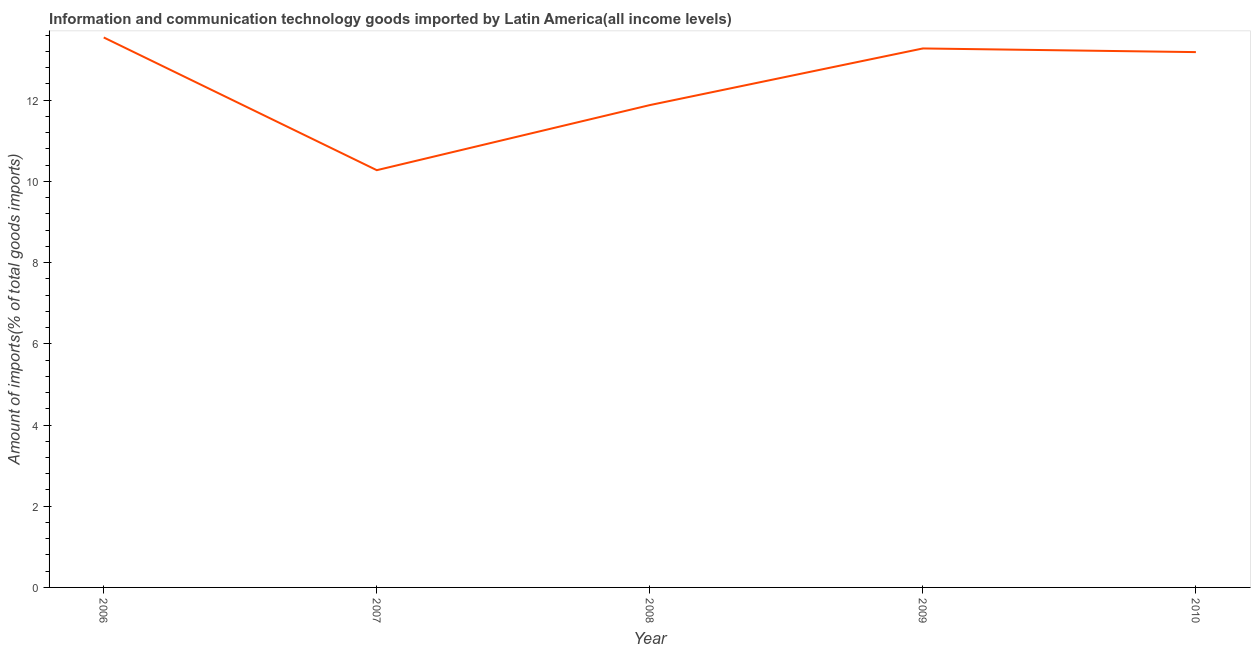What is the amount of ict goods imports in 2008?
Offer a terse response. 11.88. Across all years, what is the maximum amount of ict goods imports?
Make the answer very short. 13.54. Across all years, what is the minimum amount of ict goods imports?
Your answer should be compact. 10.28. In which year was the amount of ict goods imports maximum?
Offer a very short reply. 2006. What is the sum of the amount of ict goods imports?
Provide a short and direct response. 62.16. What is the difference between the amount of ict goods imports in 2007 and 2010?
Your answer should be compact. -2.91. What is the average amount of ict goods imports per year?
Your answer should be compact. 12.43. What is the median amount of ict goods imports?
Your answer should be compact. 13.18. What is the ratio of the amount of ict goods imports in 2006 to that in 2008?
Your response must be concise. 1.14. Is the amount of ict goods imports in 2006 less than that in 2010?
Your answer should be very brief. No. Is the difference between the amount of ict goods imports in 2007 and 2010 greater than the difference between any two years?
Make the answer very short. No. What is the difference between the highest and the second highest amount of ict goods imports?
Offer a very short reply. 0.27. Is the sum of the amount of ict goods imports in 2006 and 2008 greater than the maximum amount of ict goods imports across all years?
Your response must be concise. Yes. What is the difference between the highest and the lowest amount of ict goods imports?
Offer a very short reply. 3.27. In how many years, is the amount of ict goods imports greater than the average amount of ict goods imports taken over all years?
Your answer should be very brief. 3. Does the amount of ict goods imports monotonically increase over the years?
Keep it short and to the point. No. What is the difference between two consecutive major ticks on the Y-axis?
Provide a short and direct response. 2. What is the title of the graph?
Keep it short and to the point. Information and communication technology goods imported by Latin America(all income levels). What is the label or title of the Y-axis?
Ensure brevity in your answer.  Amount of imports(% of total goods imports). What is the Amount of imports(% of total goods imports) of 2006?
Make the answer very short. 13.54. What is the Amount of imports(% of total goods imports) in 2007?
Make the answer very short. 10.28. What is the Amount of imports(% of total goods imports) in 2008?
Your answer should be compact. 11.88. What is the Amount of imports(% of total goods imports) of 2009?
Give a very brief answer. 13.27. What is the Amount of imports(% of total goods imports) of 2010?
Your answer should be very brief. 13.18. What is the difference between the Amount of imports(% of total goods imports) in 2006 and 2007?
Provide a succinct answer. 3.27. What is the difference between the Amount of imports(% of total goods imports) in 2006 and 2008?
Make the answer very short. 1.67. What is the difference between the Amount of imports(% of total goods imports) in 2006 and 2009?
Your response must be concise. 0.27. What is the difference between the Amount of imports(% of total goods imports) in 2006 and 2010?
Ensure brevity in your answer.  0.36. What is the difference between the Amount of imports(% of total goods imports) in 2007 and 2008?
Ensure brevity in your answer.  -1.6. What is the difference between the Amount of imports(% of total goods imports) in 2007 and 2009?
Your answer should be compact. -3. What is the difference between the Amount of imports(% of total goods imports) in 2007 and 2010?
Provide a succinct answer. -2.91. What is the difference between the Amount of imports(% of total goods imports) in 2008 and 2009?
Offer a terse response. -1.4. What is the difference between the Amount of imports(% of total goods imports) in 2008 and 2010?
Offer a very short reply. -1.3. What is the difference between the Amount of imports(% of total goods imports) in 2009 and 2010?
Offer a terse response. 0.09. What is the ratio of the Amount of imports(% of total goods imports) in 2006 to that in 2007?
Ensure brevity in your answer.  1.32. What is the ratio of the Amount of imports(% of total goods imports) in 2006 to that in 2008?
Give a very brief answer. 1.14. What is the ratio of the Amount of imports(% of total goods imports) in 2006 to that in 2009?
Keep it short and to the point. 1.02. What is the ratio of the Amount of imports(% of total goods imports) in 2006 to that in 2010?
Keep it short and to the point. 1.03. What is the ratio of the Amount of imports(% of total goods imports) in 2007 to that in 2008?
Make the answer very short. 0.86. What is the ratio of the Amount of imports(% of total goods imports) in 2007 to that in 2009?
Your response must be concise. 0.77. What is the ratio of the Amount of imports(% of total goods imports) in 2007 to that in 2010?
Your answer should be very brief. 0.78. What is the ratio of the Amount of imports(% of total goods imports) in 2008 to that in 2009?
Your response must be concise. 0.9. What is the ratio of the Amount of imports(% of total goods imports) in 2008 to that in 2010?
Offer a terse response. 0.9. What is the ratio of the Amount of imports(% of total goods imports) in 2009 to that in 2010?
Provide a succinct answer. 1.01. 